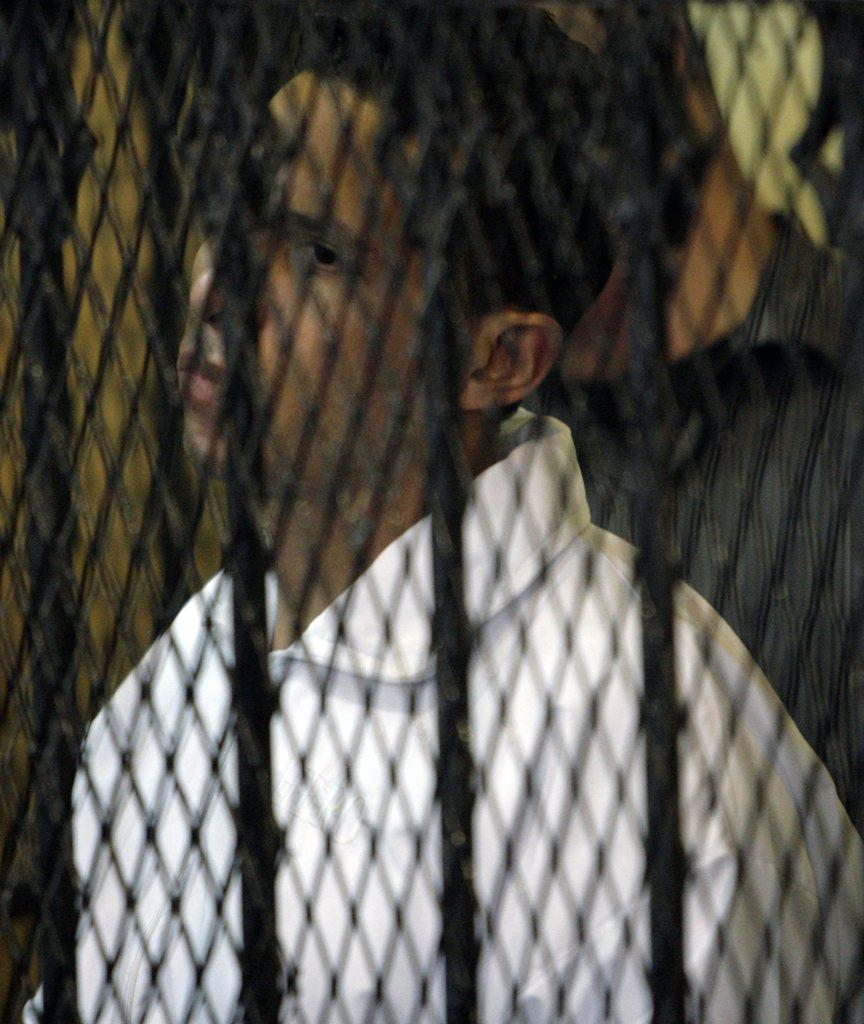What type of material can be seen in the image? There is a mesh in the image. Who or what is present in the image? There are people in the image. What type of wound can be seen on the beginner's guide in the image? There is no guide or wound present in the image; it only features a mesh and people. 